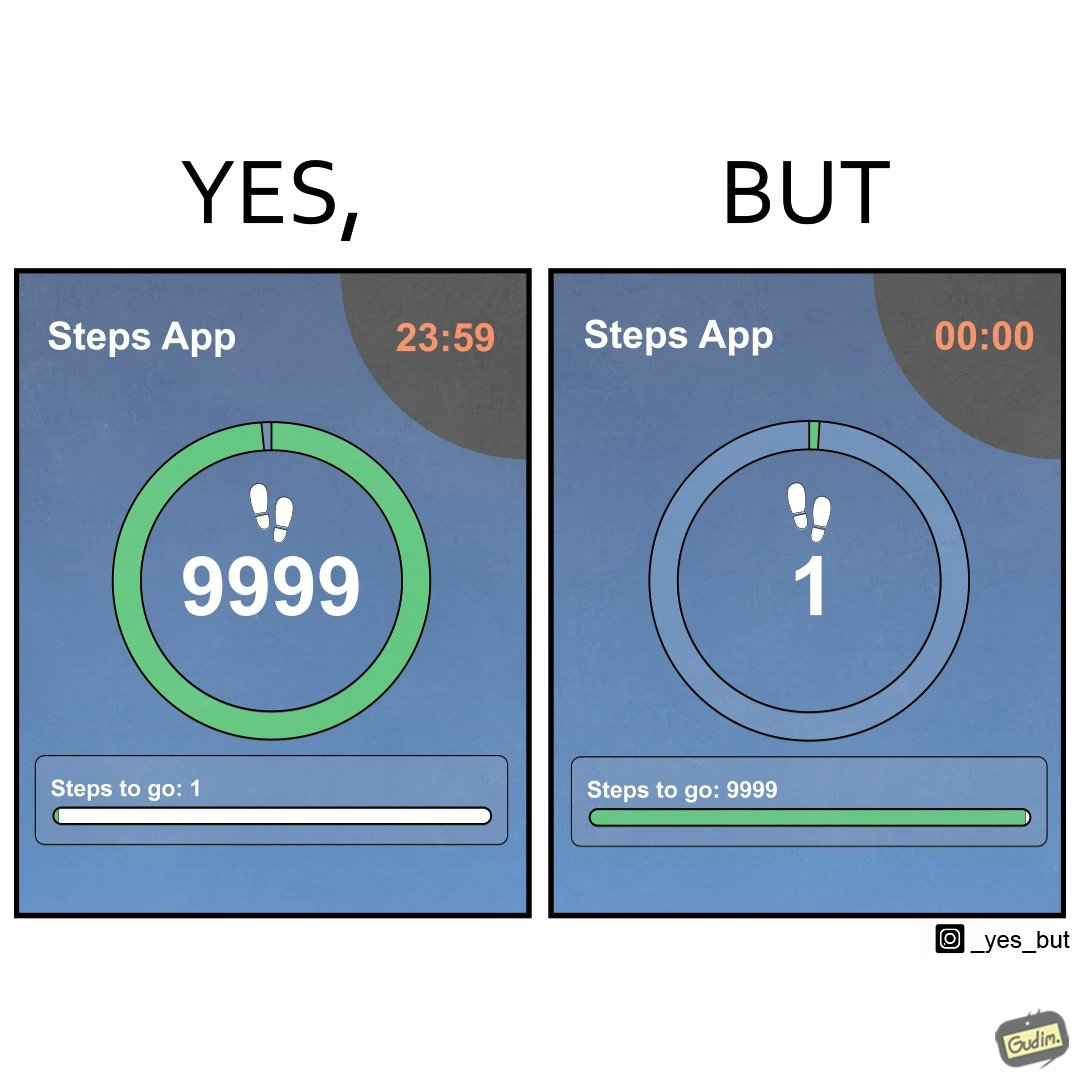Describe the content of this image. The images are funny since they show how close the user is to hitting his daily target of 10000 steps, but as soon as it is midnight, the step counter resets and the user misses his daily target by one step. Once the clock resets he is 9999 steps away from his target 